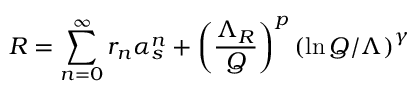<formula> <loc_0><loc_0><loc_500><loc_500>R = \sum _ { n = 0 } ^ { \infty } r _ { n } \alpha _ { s } ^ { n } + \left ( \frac { \Lambda _ { R } } { Q } \right ) ^ { p } \left ( \ln Q / \Lambda \right ) ^ { \gamma }</formula> 